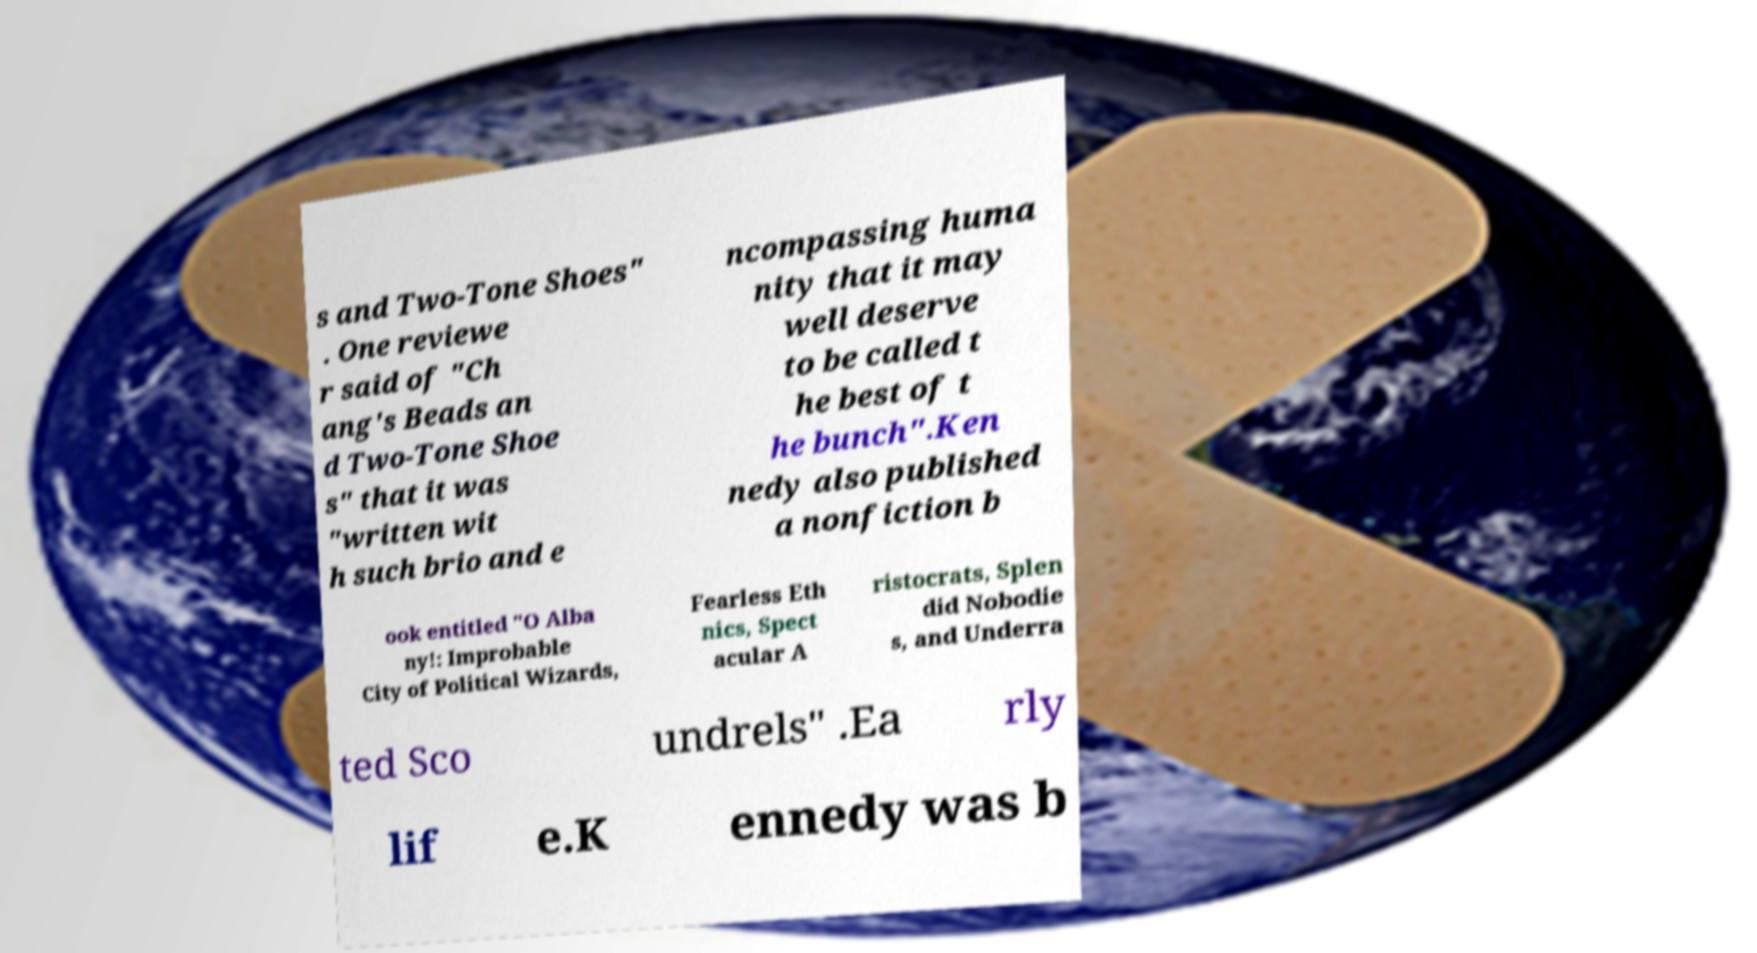Can you read and provide the text displayed in the image?This photo seems to have some interesting text. Can you extract and type it out for me? s and Two-Tone Shoes" . One reviewe r said of "Ch ang's Beads an d Two-Tone Shoe s" that it was "written wit h such brio and e ncompassing huma nity that it may well deserve to be called t he best of t he bunch".Ken nedy also published a nonfiction b ook entitled "O Alba ny!: Improbable City of Political Wizards, Fearless Eth nics, Spect acular A ristocrats, Splen did Nobodie s, and Underra ted Sco undrels" .Ea rly lif e.K ennedy was b 